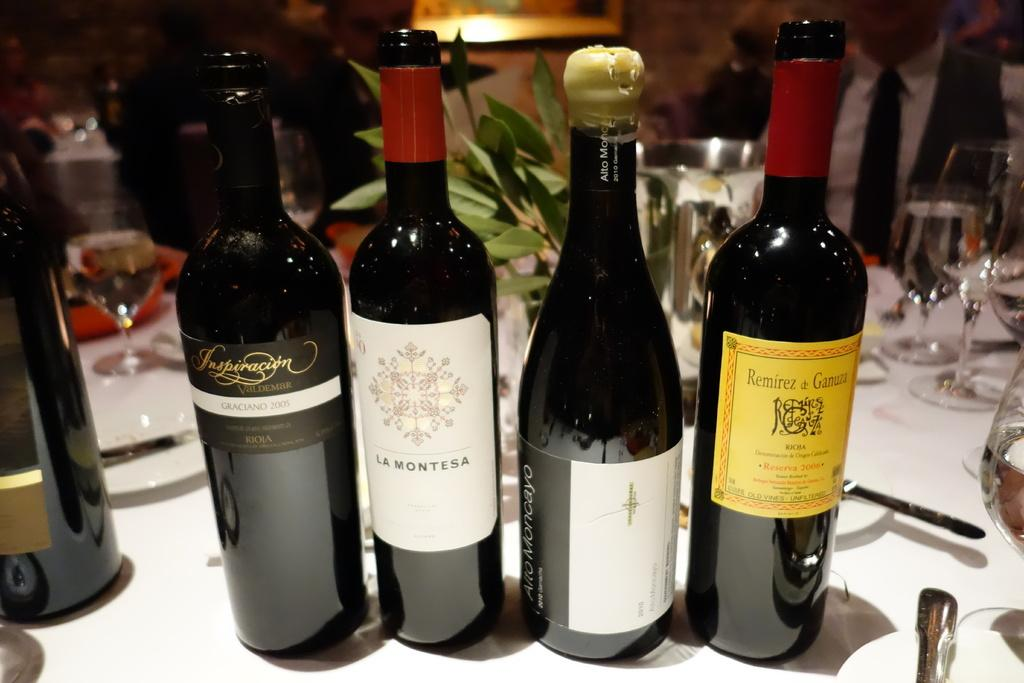<image>
Summarize the visual content of the image. Bottles of wine are lined up on a table, most labels facing forward including a La Montesa. 